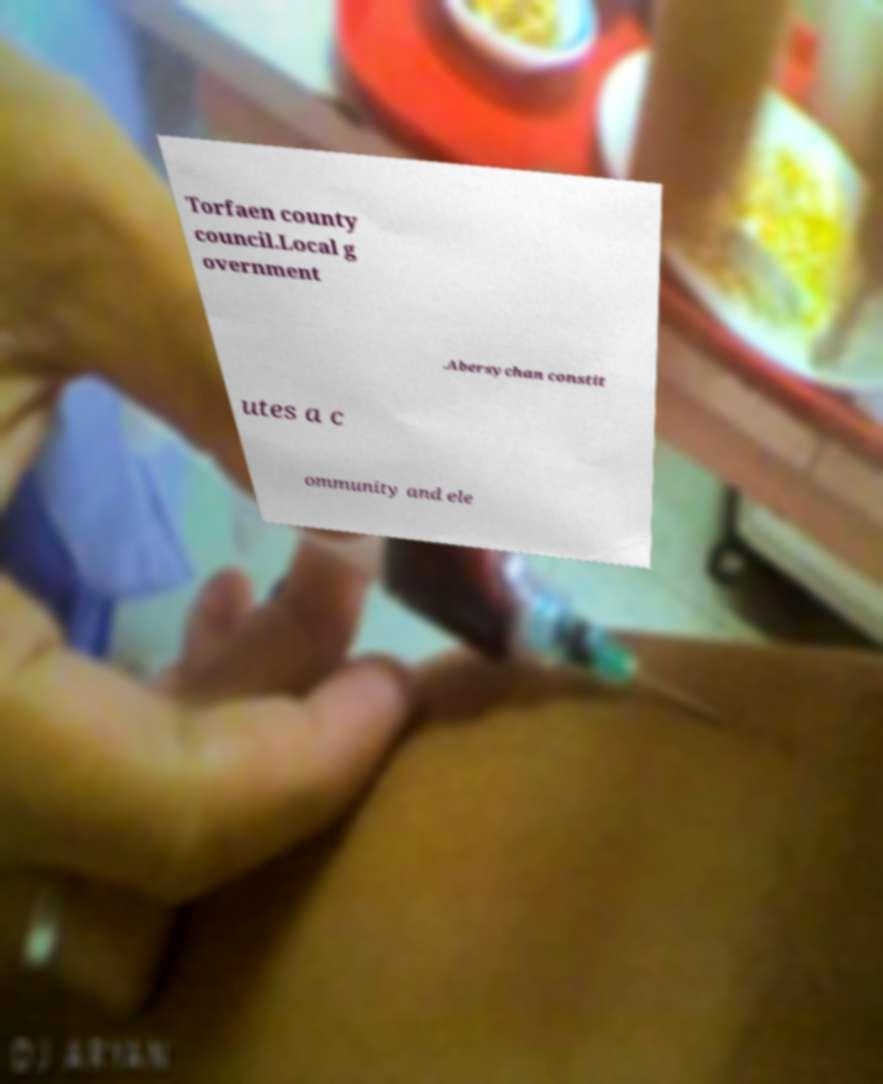Can you read and provide the text displayed in the image?This photo seems to have some interesting text. Can you extract and type it out for me? Torfaen county council.Local g overnment .Abersychan constit utes a c ommunity and ele 